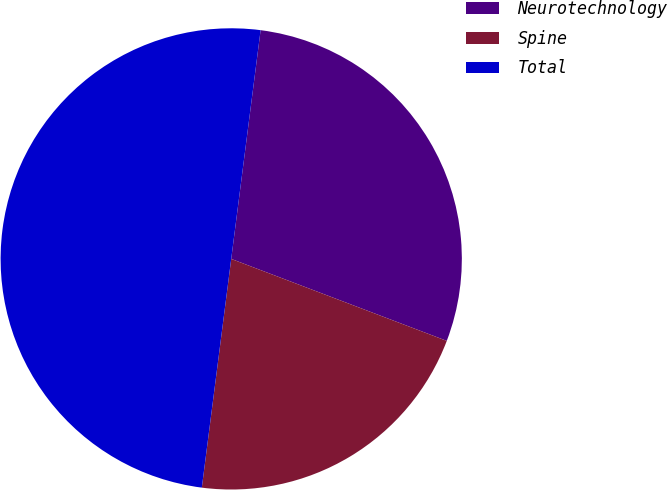Convert chart. <chart><loc_0><loc_0><loc_500><loc_500><pie_chart><fcel>Neurotechnology<fcel>Spine<fcel>Total<nl><fcel>28.75%<fcel>21.25%<fcel>50.0%<nl></chart> 